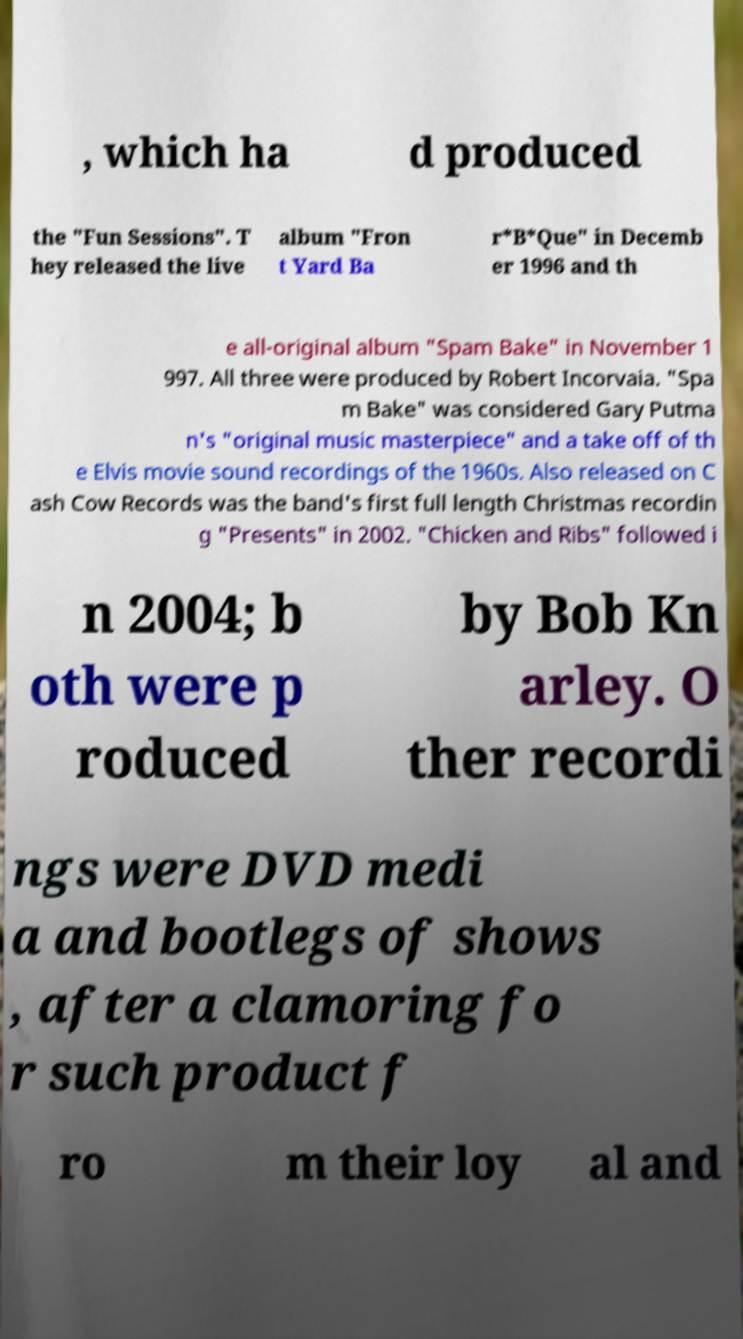There's text embedded in this image that I need extracted. Can you transcribe it verbatim? , which ha d produced the "Fun Sessions". T hey released the live album "Fron t Yard Ba r*B*Que" in Decemb er 1996 and th e all-original album "Spam Bake" in November 1 997. All three were produced by Robert Incorvaia. "Spa m Bake" was considered Gary Putma n's "original music masterpiece" and a take off of th e Elvis movie sound recordings of the 1960s. Also released on C ash Cow Records was the band's first full length Christmas recordin g "Presents" in 2002. "Chicken and Ribs" followed i n 2004; b oth were p roduced by Bob Kn arley. O ther recordi ngs were DVD medi a and bootlegs of shows , after a clamoring fo r such product f ro m their loy al and 